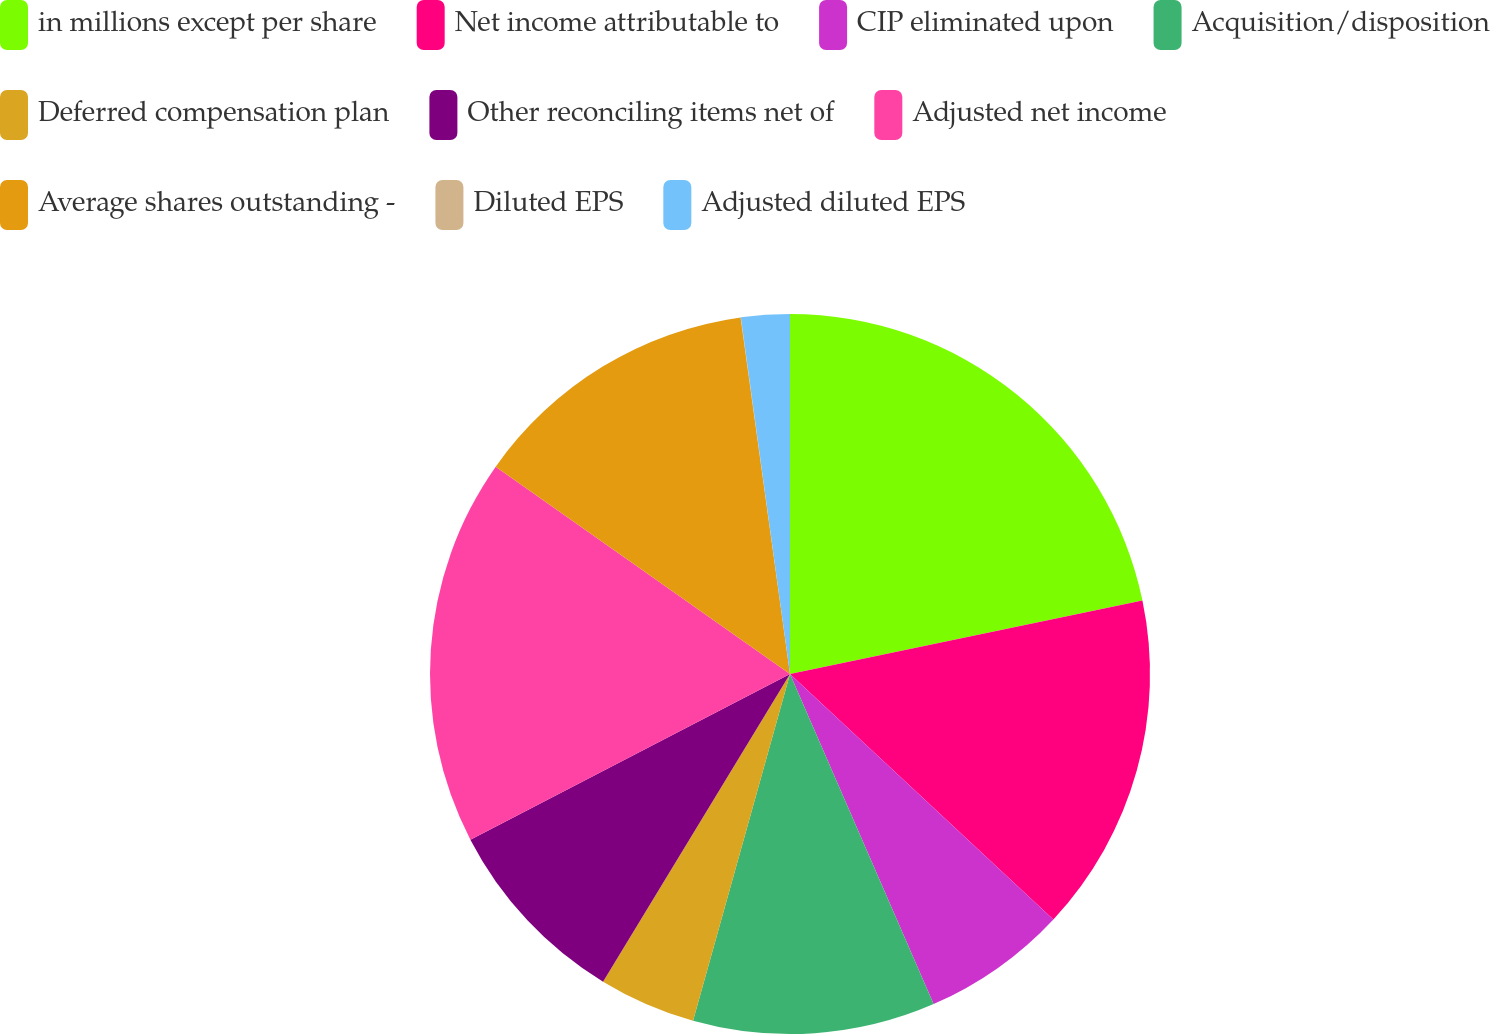<chart> <loc_0><loc_0><loc_500><loc_500><pie_chart><fcel>in millions except per share<fcel>Net income attributable to<fcel>CIP eliminated upon<fcel>Acquisition/disposition<fcel>Deferred compensation plan<fcel>Other reconciling items net of<fcel>Adjusted net income<fcel>Average shares outstanding -<fcel>Diluted EPS<fcel>Adjusted diluted EPS<nl><fcel>21.73%<fcel>15.21%<fcel>6.53%<fcel>10.87%<fcel>4.35%<fcel>8.7%<fcel>17.38%<fcel>13.04%<fcel>0.01%<fcel>2.18%<nl></chart> 